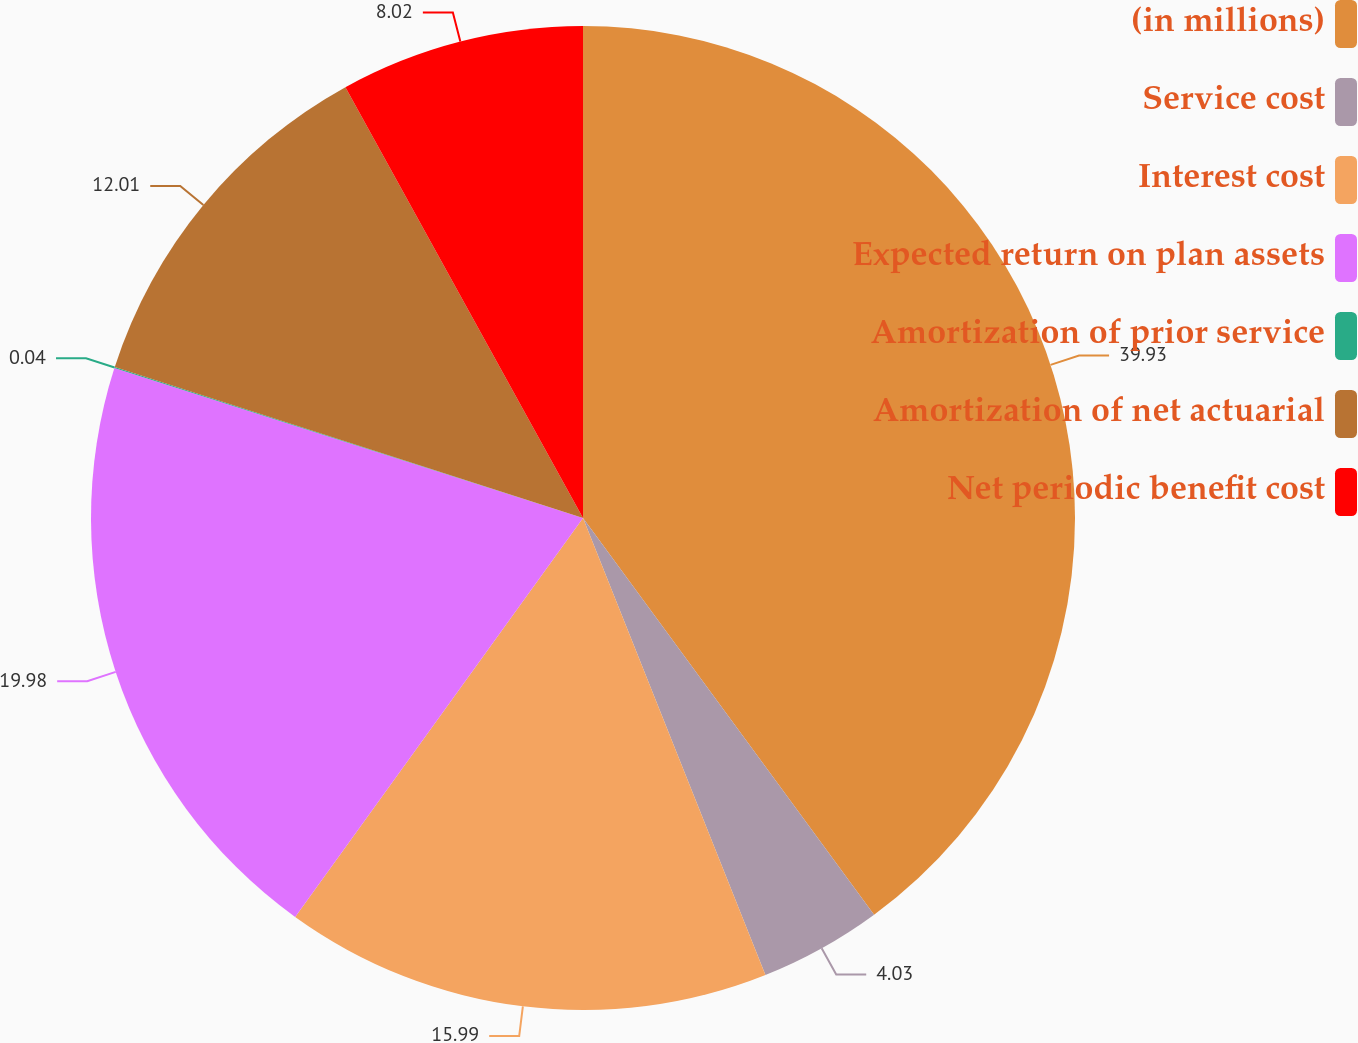<chart> <loc_0><loc_0><loc_500><loc_500><pie_chart><fcel>(in millions)<fcel>Service cost<fcel>Interest cost<fcel>Expected return on plan assets<fcel>Amortization of prior service<fcel>Amortization of net actuarial<fcel>Net periodic benefit cost<nl><fcel>39.92%<fcel>4.03%<fcel>15.99%<fcel>19.98%<fcel>0.04%<fcel>12.01%<fcel>8.02%<nl></chart> 